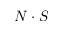Convert formula to latex. <formula><loc_0><loc_0><loc_500><loc_500>N \cdot S</formula> 